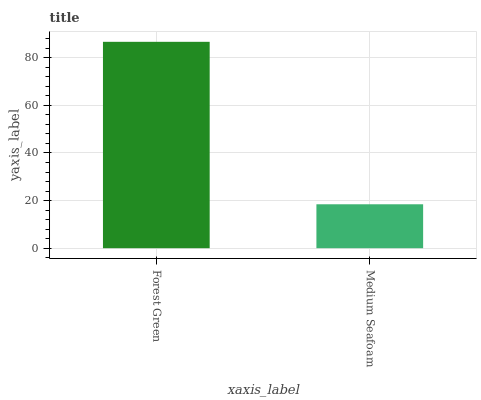Is Medium Seafoam the minimum?
Answer yes or no. Yes. Is Forest Green the maximum?
Answer yes or no. Yes. Is Medium Seafoam the maximum?
Answer yes or no. No. Is Forest Green greater than Medium Seafoam?
Answer yes or no. Yes. Is Medium Seafoam less than Forest Green?
Answer yes or no. Yes. Is Medium Seafoam greater than Forest Green?
Answer yes or no. No. Is Forest Green less than Medium Seafoam?
Answer yes or no. No. Is Forest Green the high median?
Answer yes or no. Yes. Is Medium Seafoam the low median?
Answer yes or no. Yes. Is Medium Seafoam the high median?
Answer yes or no. No. Is Forest Green the low median?
Answer yes or no. No. 